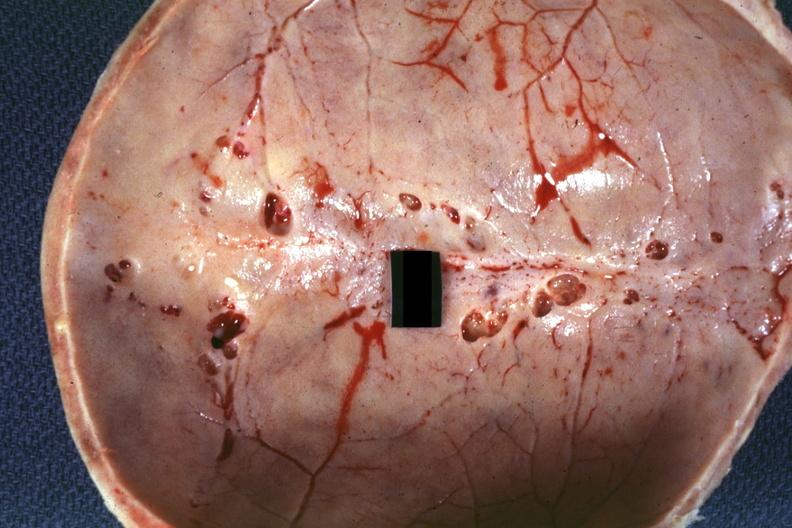where does this image show?
Answer the question using a single word or phrase. Inner table view multiple venous lakes 